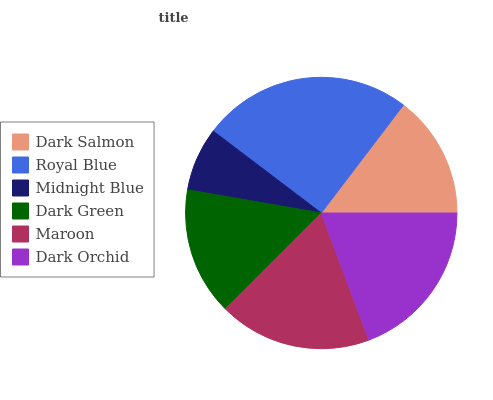Is Midnight Blue the minimum?
Answer yes or no. Yes. Is Royal Blue the maximum?
Answer yes or no. Yes. Is Royal Blue the minimum?
Answer yes or no. No. Is Midnight Blue the maximum?
Answer yes or no. No. Is Royal Blue greater than Midnight Blue?
Answer yes or no. Yes. Is Midnight Blue less than Royal Blue?
Answer yes or no. Yes. Is Midnight Blue greater than Royal Blue?
Answer yes or no. No. Is Royal Blue less than Midnight Blue?
Answer yes or no. No. Is Maroon the high median?
Answer yes or no. Yes. Is Dark Green the low median?
Answer yes or no. Yes. Is Midnight Blue the high median?
Answer yes or no. No. Is Maroon the low median?
Answer yes or no. No. 